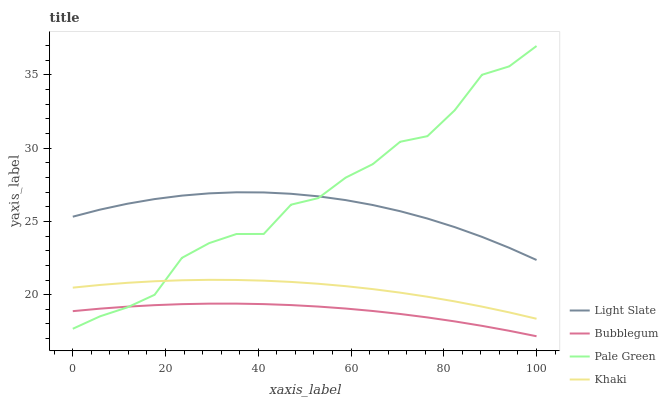Does Bubblegum have the minimum area under the curve?
Answer yes or no. Yes. Does Pale Green have the maximum area under the curve?
Answer yes or no. Yes. Does Khaki have the minimum area under the curve?
Answer yes or no. No. Does Khaki have the maximum area under the curve?
Answer yes or no. No. Is Bubblegum the smoothest?
Answer yes or no. Yes. Is Pale Green the roughest?
Answer yes or no. Yes. Is Khaki the smoothest?
Answer yes or no. No. Is Khaki the roughest?
Answer yes or no. No. Does Bubblegum have the lowest value?
Answer yes or no. Yes. Does Pale Green have the lowest value?
Answer yes or no. No. Does Pale Green have the highest value?
Answer yes or no. Yes. Does Khaki have the highest value?
Answer yes or no. No. Is Bubblegum less than Khaki?
Answer yes or no. Yes. Is Khaki greater than Bubblegum?
Answer yes or no. Yes. Does Pale Green intersect Light Slate?
Answer yes or no. Yes. Is Pale Green less than Light Slate?
Answer yes or no. No. Is Pale Green greater than Light Slate?
Answer yes or no. No. Does Bubblegum intersect Khaki?
Answer yes or no. No. 